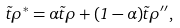<formula> <loc_0><loc_0><loc_500><loc_500>\vec { t } { \rho ^ { * } } = \alpha \vec { t } { \rho } + ( 1 - \alpha ) \vec { t } { \rho } ^ { \prime \prime } ,</formula> 